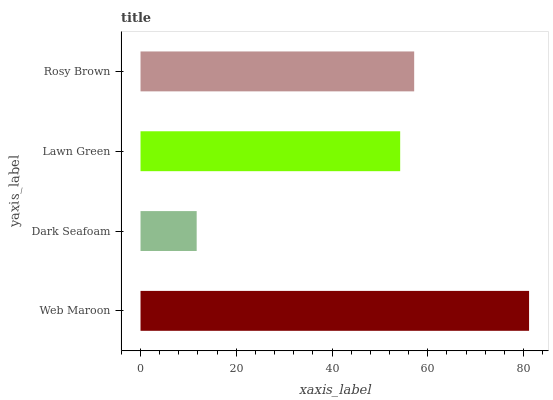Is Dark Seafoam the minimum?
Answer yes or no. Yes. Is Web Maroon the maximum?
Answer yes or no. Yes. Is Lawn Green the minimum?
Answer yes or no. No. Is Lawn Green the maximum?
Answer yes or no. No. Is Lawn Green greater than Dark Seafoam?
Answer yes or no. Yes. Is Dark Seafoam less than Lawn Green?
Answer yes or no. Yes. Is Dark Seafoam greater than Lawn Green?
Answer yes or no. No. Is Lawn Green less than Dark Seafoam?
Answer yes or no. No. Is Rosy Brown the high median?
Answer yes or no. Yes. Is Lawn Green the low median?
Answer yes or no. Yes. Is Dark Seafoam the high median?
Answer yes or no. No. Is Dark Seafoam the low median?
Answer yes or no. No. 